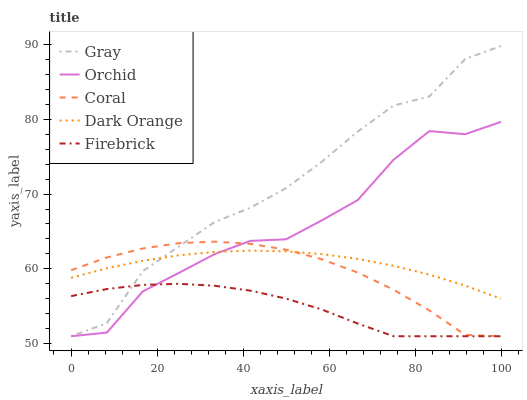Does Firebrick have the minimum area under the curve?
Answer yes or no. Yes. Does Gray have the maximum area under the curve?
Answer yes or no. Yes. Does Coral have the minimum area under the curve?
Answer yes or no. No. Does Coral have the maximum area under the curve?
Answer yes or no. No. Is Dark Orange the smoothest?
Answer yes or no. Yes. Is Orchid the roughest?
Answer yes or no. Yes. Is Gray the smoothest?
Answer yes or no. No. Is Gray the roughest?
Answer yes or no. No. Does Gray have the lowest value?
Answer yes or no. Yes. Does Gray have the highest value?
Answer yes or no. Yes. Does Coral have the highest value?
Answer yes or no. No. Is Firebrick less than Dark Orange?
Answer yes or no. Yes. Is Dark Orange greater than Firebrick?
Answer yes or no. Yes. Does Firebrick intersect Coral?
Answer yes or no. Yes. Is Firebrick less than Coral?
Answer yes or no. No. Is Firebrick greater than Coral?
Answer yes or no. No. Does Firebrick intersect Dark Orange?
Answer yes or no. No. 